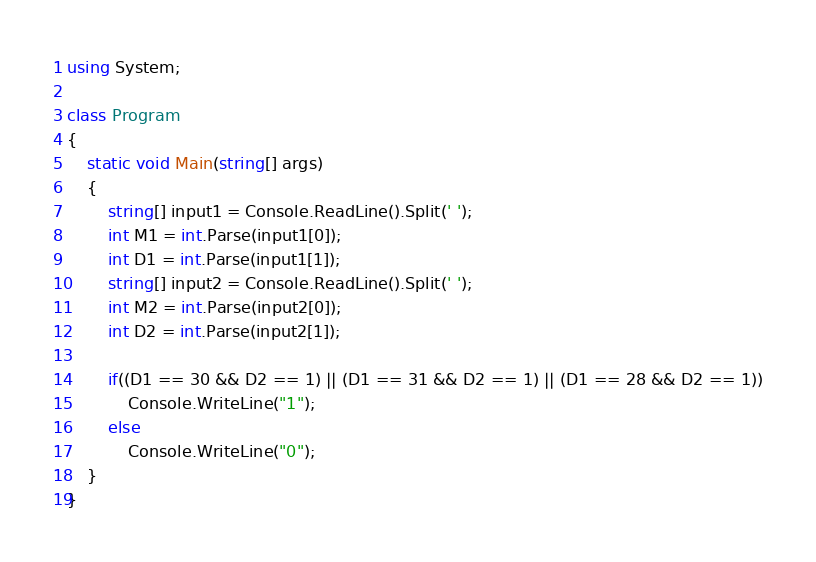<code> <loc_0><loc_0><loc_500><loc_500><_C#_>using System;

class Program
{
    static void Main(string[] args)
    {
        string[] input1 = Console.ReadLine().Split(' ');
        int M1 = int.Parse(input1[0]);
        int D1 = int.Parse(input1[1]);
        string[] input2 = Console.ReadLine().Split(' ');
        int M2 = int.Parse(input2[0]);
        int D2 = int.Parse(input2[1]);

        if((D1 == 30 && D2 == 1) || (D1 == 31 && D2 == 1) || (D1 == 28 && D2 == 1))
            Console.WriteLine("1");
        else
            Console.WriteLine("0");
    }
}
</code> 